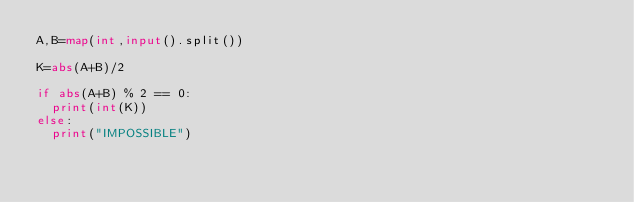<code> <loc_0><loc_0><loc_500><loc_500><_Python_>A,B=map(int,input().split())

K=abs(A+B)/2

if abs(A+B) % 2 == 0:
  print(int(K))
else:
  print("IMPOSSIBLE")</code> 